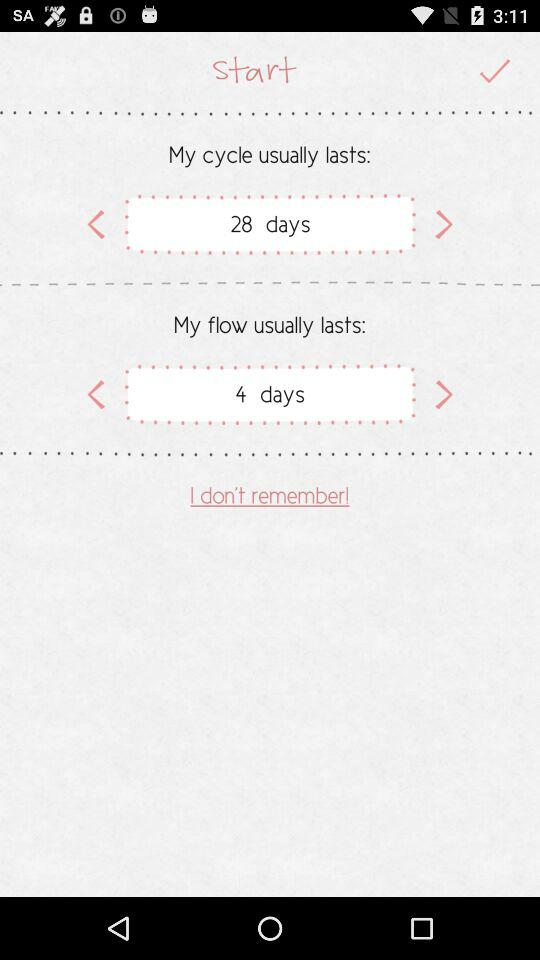How many days shorter does the user's cycle usually last than 30 days?
Answer the question using a single word or phrase. 2 